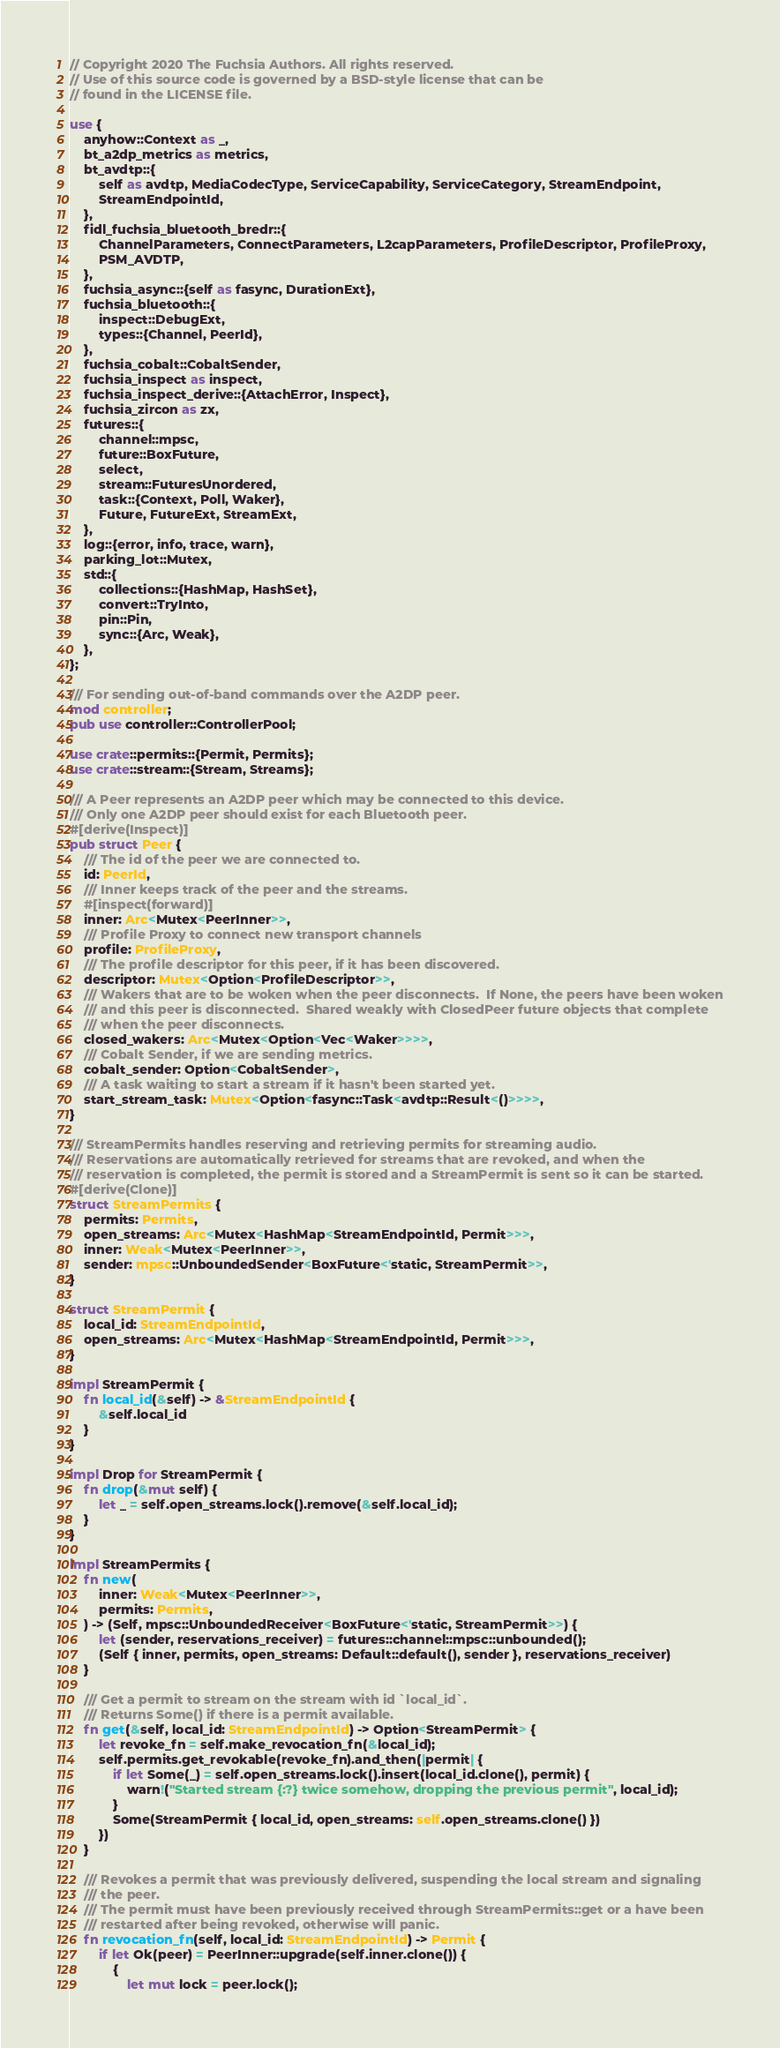Convert code to text. <code><loc_0><loc_0><loc_500><loc_500><_Rust_>// Copyright 2020 The Fuchsia Authors. All rights reserved.
// Use of this source code is governed by a BSD-style license that can be
// found in the LICENSE file.

use {
    anyhow::Context as _,
    bt_a2dp_metrics as metrics,
    bt_avdtp::{
        self as avdtp, MediaCodecType, ServiceCapability, ServiceCategory, StreamEndpoint,
        StreamEndpointId,
    },
    fidl_fuchsia_bluetooth_bredr::{
        ChannelParameters, ConnectParameters, L2capParameters, ProfileDescriptor, ProfileProxy,
        PSM_AVDTP,
    },
    fuchsia_async::{self as fasync, DurationExt},
    fuchsia_bluetooth::{
        inspect::DebugExt,
        types::{Channel, PeerId},
    },
    fuchsia_cobalt::CobaltSender,
    fuchsia_inspect as inspect,
    fuchsia_inspect_derive::{AttachError, Inspect},
    fuchsia_zircon as zx,
    futures::{
        channel::mpsc,
        future::BoxFuture,
        select,
        stream::FuturesUnordered,
        task::{Context, Poll, Waker},
        Future, FutureExt, StreamExt,
    },
    log::{error, info, trace, warn},
    parking_lot::Mutex,
    std::{
        collections::{HashMap, HashSet},
        convert::TryInto,
        pin::Pin,
        sync::{Arc, Weak},
    },
};

/// For sending out-of-band commands over the A2DP peer.
mod controller;
pub use controller::ControllerPool;

use crate::permits::{Permit, Permits};
use crate::stream::{Stream, Streams};

/// A Peer represents an A2DP peer which may be connected to this device.
/// Only one A2DP peer should exist for each Bluetooth peer.
#[derive(Inspect)]
pub struct Peer {
    /// The id of the peer we are connected to.
    id: PeerId,
    /// Inner keeps track of the peer and the streams.
    #[inspect(forward)]
    inner: Arc<Mutex<PeerInner>>,
    /// Profile Proxy to connect new transport channels
    profile: ProfileProxy,
    /// The profile descriptor for this peer, if it has been discovered.
    descriptor: Mutex<Option<ProfileDescriptor>>,
    /// Wakers that are to be woken when the peer disconnects.  If None, the peers have been woken
    /// and this peer is disconnected.  Shared weakly with ClosedPeer future objects that complete
    /// when the peer disconnects.
    closed_wakers: Arc<Mutex<Option<Vec<Waker>>>>,
    /// Cobalt Sender, if we are sending metrics.
    cobalt_sender: Option<CobaltSender>,
    /// A task waiting to start a stream if it hasn't been started yet.
    start_stream_task: Mutex<Option<fasync::Task<avdtp::Result<()>>>>,
}

/// StreamPermits handles reserving and retrieving permits for streaming audio.
/// Reservations are automatically retrieved for streams that are revoked, and when the
/// reservation is completed, the permit is stored and a StreamPermit is sent so it can be started.
#[derive(Clone)]
struct StreamPermits {
    permits: Permits,
    open_streams: Arc<Mutex<HashMap<StreamEndpointId, Permit>>>,
    inner: Weak<Mutex<PeerInner>>,
    sender: mpsc::UnboundedSender<BoxFuture<'static, StreamPermit>>,
}

struct StreamPermit {
    local_id: StreamEndpointId,
    open_streams: Arc<Mutex<HashMap<StreamEndpointId, Permit>>>,
}

impl StreamPermit {
    fn local_id(&self) -> &StreamEndpointId {
        &self.local_id
    }
}

impl Drop for StreamPermit {
    fn drop(&mut self) {
        let _ = self.open_streams.lock().remove(&self.local_id);
    }
}

impl StreamPermits {
    fn new(
        inner: Weak<Mutex<PeerInner>>,
        permits: Permits,
    ) -> (Self, mpsc::UnboundedReceiver<BoxFuture<'static, StreamPermit>>) {
        let (sender, reservations_receiver) = futures::channel::mpsc::unbounded();
        (Self { inner, permits, open_streams: Default::default(), sender }, reservations_receiver)
    }

    /// Get a permit to stream on the stream with id `local_id`.
    /// Returns Some() if there is a permit available.
    fn get(&self, local_id: StreamEndpointId) -> Option<StreamPermit> {
        let revoke_fn = self.make_revocation_fn(&local_id);
        self.permits.get_revokable(revoke_fn).and_then(|permit| {
            if let Some(_) = self.open_streams.lock().insert(local_id.clone(), permit) {
                warn!("Started stream {:?} twice somehow, dropping the previous permit", local_id);
            }
            Some(StreamPermit { local_id, open_streams: self.open_streams.clone() })
        })
    }

    /// Revokes a permit that was previously delivered, suspending the local stream and signaling
    /// the peer.
    /// The permit must have been previously received through StreamPermits::get or a have been
    /// restarted after being revoked, otherwise will panic.
    fn revocation_fn(self, local_id: StreamEndpointId) -> Permit {
        if let Ok(peer) = PeerInner::upgrade(self.inner.clone()) {
            {
                let mut lock = peer.lock();</code> 